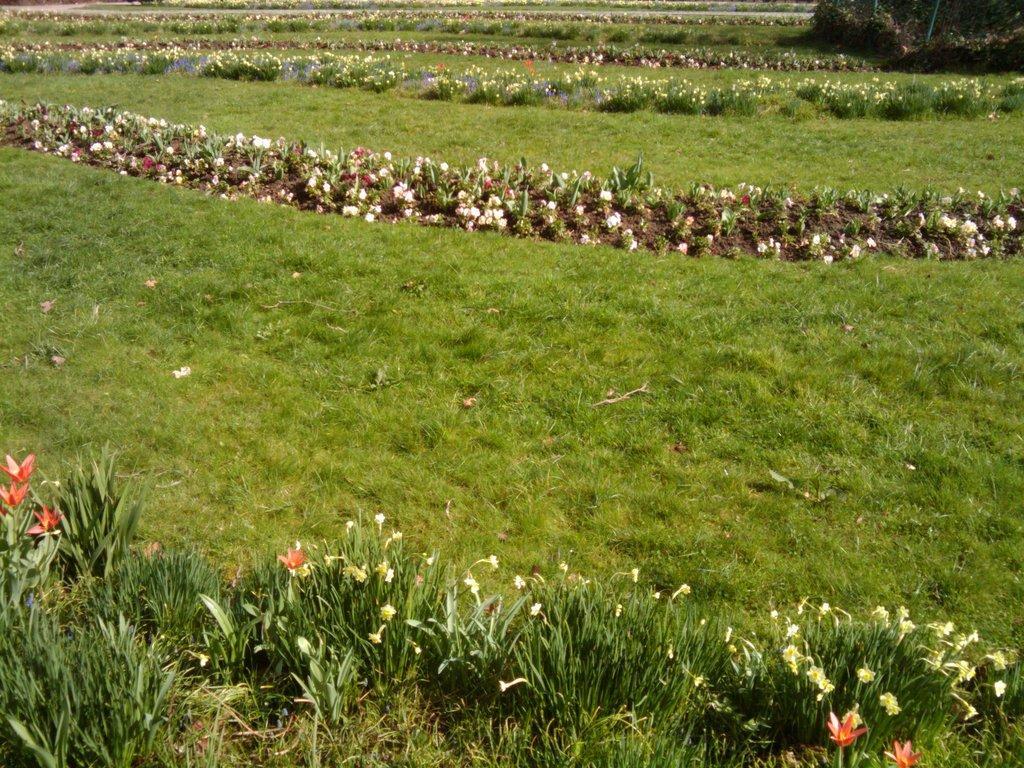How would you summarize this image in a sentence or two? In this picture we can see the grass, plants with flowers and in the background we can see some objects. 